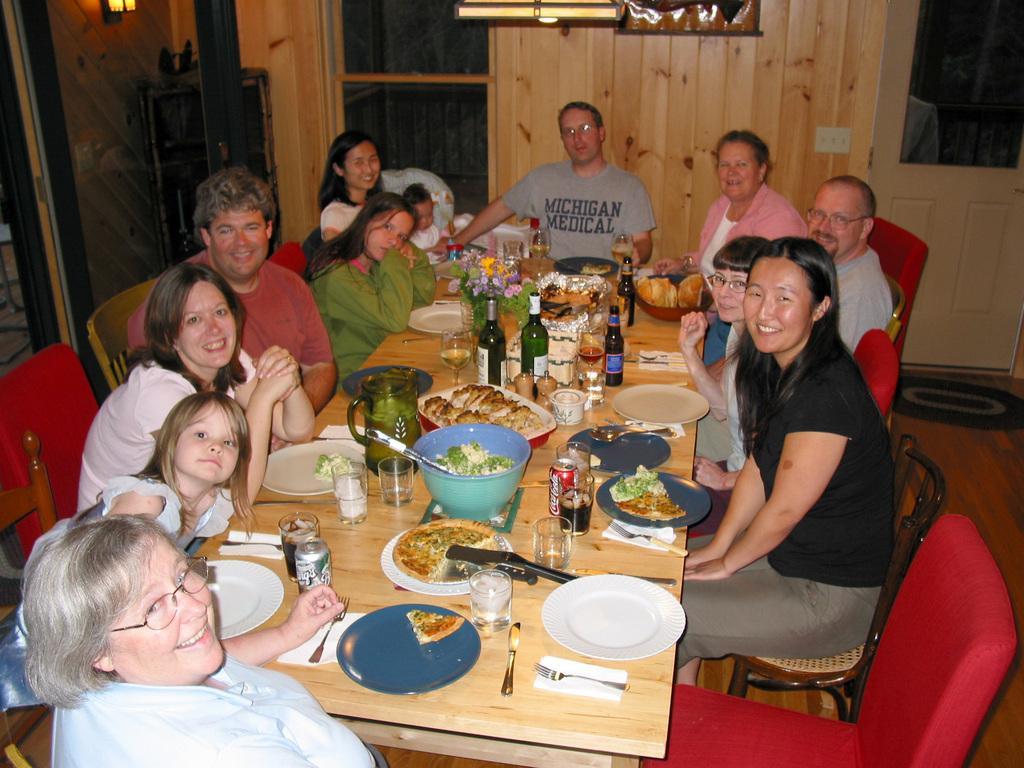Describe this image in one or two sentences. This picture is clicked inside a room. There are few people sitting on chairs at the table and they all are smiling. On the table there are glasses, plates, bowls, spoons, knives, drink cans, wine bottles, tissues and a flower vase at the center. At at the above left corner there is a lamp on the wall. Just below to it there is a wooden cupboard. In the background there is wall and door.  